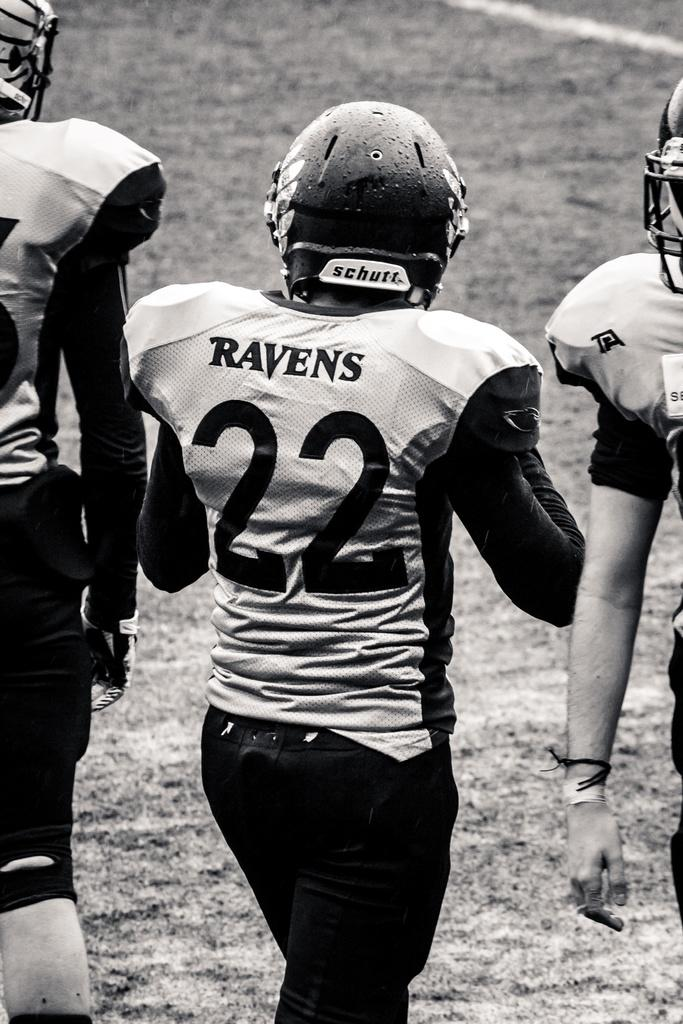What can be seen in the image? There are players in the image. What are the players wearing on their heads? The players are wearing helmets. Where are the players located in the image? The players are in the foreground area of the image. What type of environment is visible in the background of the image? The background of the image appears to be a grassland. Can you see an arch in the image? There is no arch present in the image. Are there any goats visible in the image? There are no goats present in the image. 